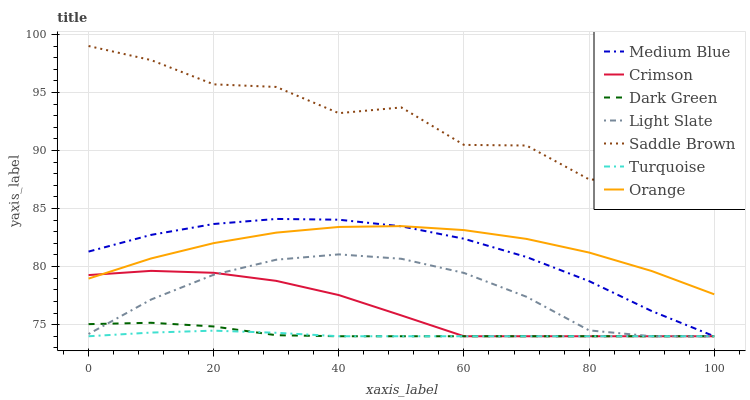Does Turquoise have the minimum area under the curve?
Answer yes or no. Yes. Does Saddle Brown have the maximum area under the curve?
Answer yes or no. Yes. Does Light Slate have the minimum area under the curve?
Answer yes or no. No. Does Light Slate have the maximum area under the curve?
Answer yes or no. No. Is Turquoise the smoothest?
Answer yes or no. Yes. Is Saddle Brown the roughest?
Answer yes or no. Yes. Is Light Slate the smoothest?
Answer yes or no. No. Is Light Slate the roughest?
Answer yes or no. No. Does Turquoise have the lowest value?
Answer yes or no. Yes. Does Orange have the lowest value?
Answer yes or no. No. Does Saddle Brown have the highest value?
Answer yes or no. Yes. Does Light Slate have the highest value?
Answer yes or no. No. Is Dark Green less than Saddle Brown?
Answer yes or no. Yes. Is Saddle Brown greater than Medium Blue?
Answer yes or no. Yes. Does Orange intersect Medium Blue?
Answer yes or no. Yes. Is Orange less than Medium Blue?
Answer yes or no. No. Is Orange greater than Medium Blue?
Answer yes or no. No. Does Dark Green intersect Saddle Brown?
Answer yes or no. No. 